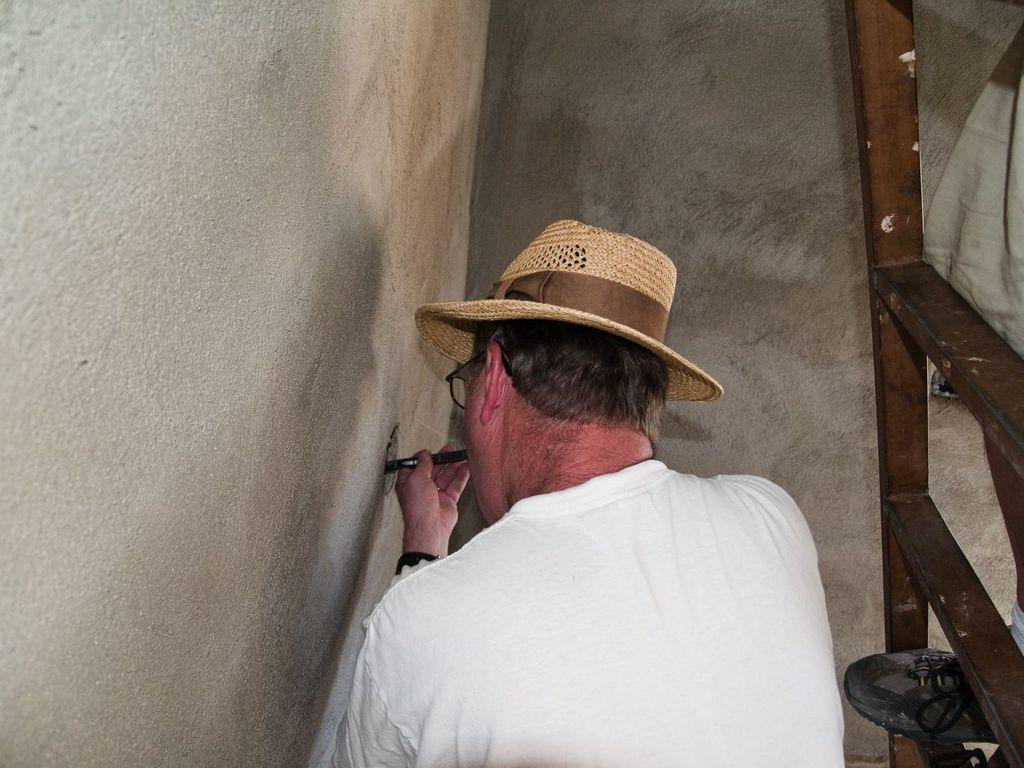What is the man in the image wearing on his upper body? The man is wearing a white t-shirt in the image. What type of headwear is the man wearing? The man is wearing a hat. What is the man holding in the image? The man is holding an object. What can be seen in the background of the image? There is a wall visible in the image. What is located on the right side of the image? There is a ladder on the right side of the image. Can you describe the person on the ladder? There is a man on the ladder. What type of pot is the man using to skate in the image? There is no pot or skate present in the image. 